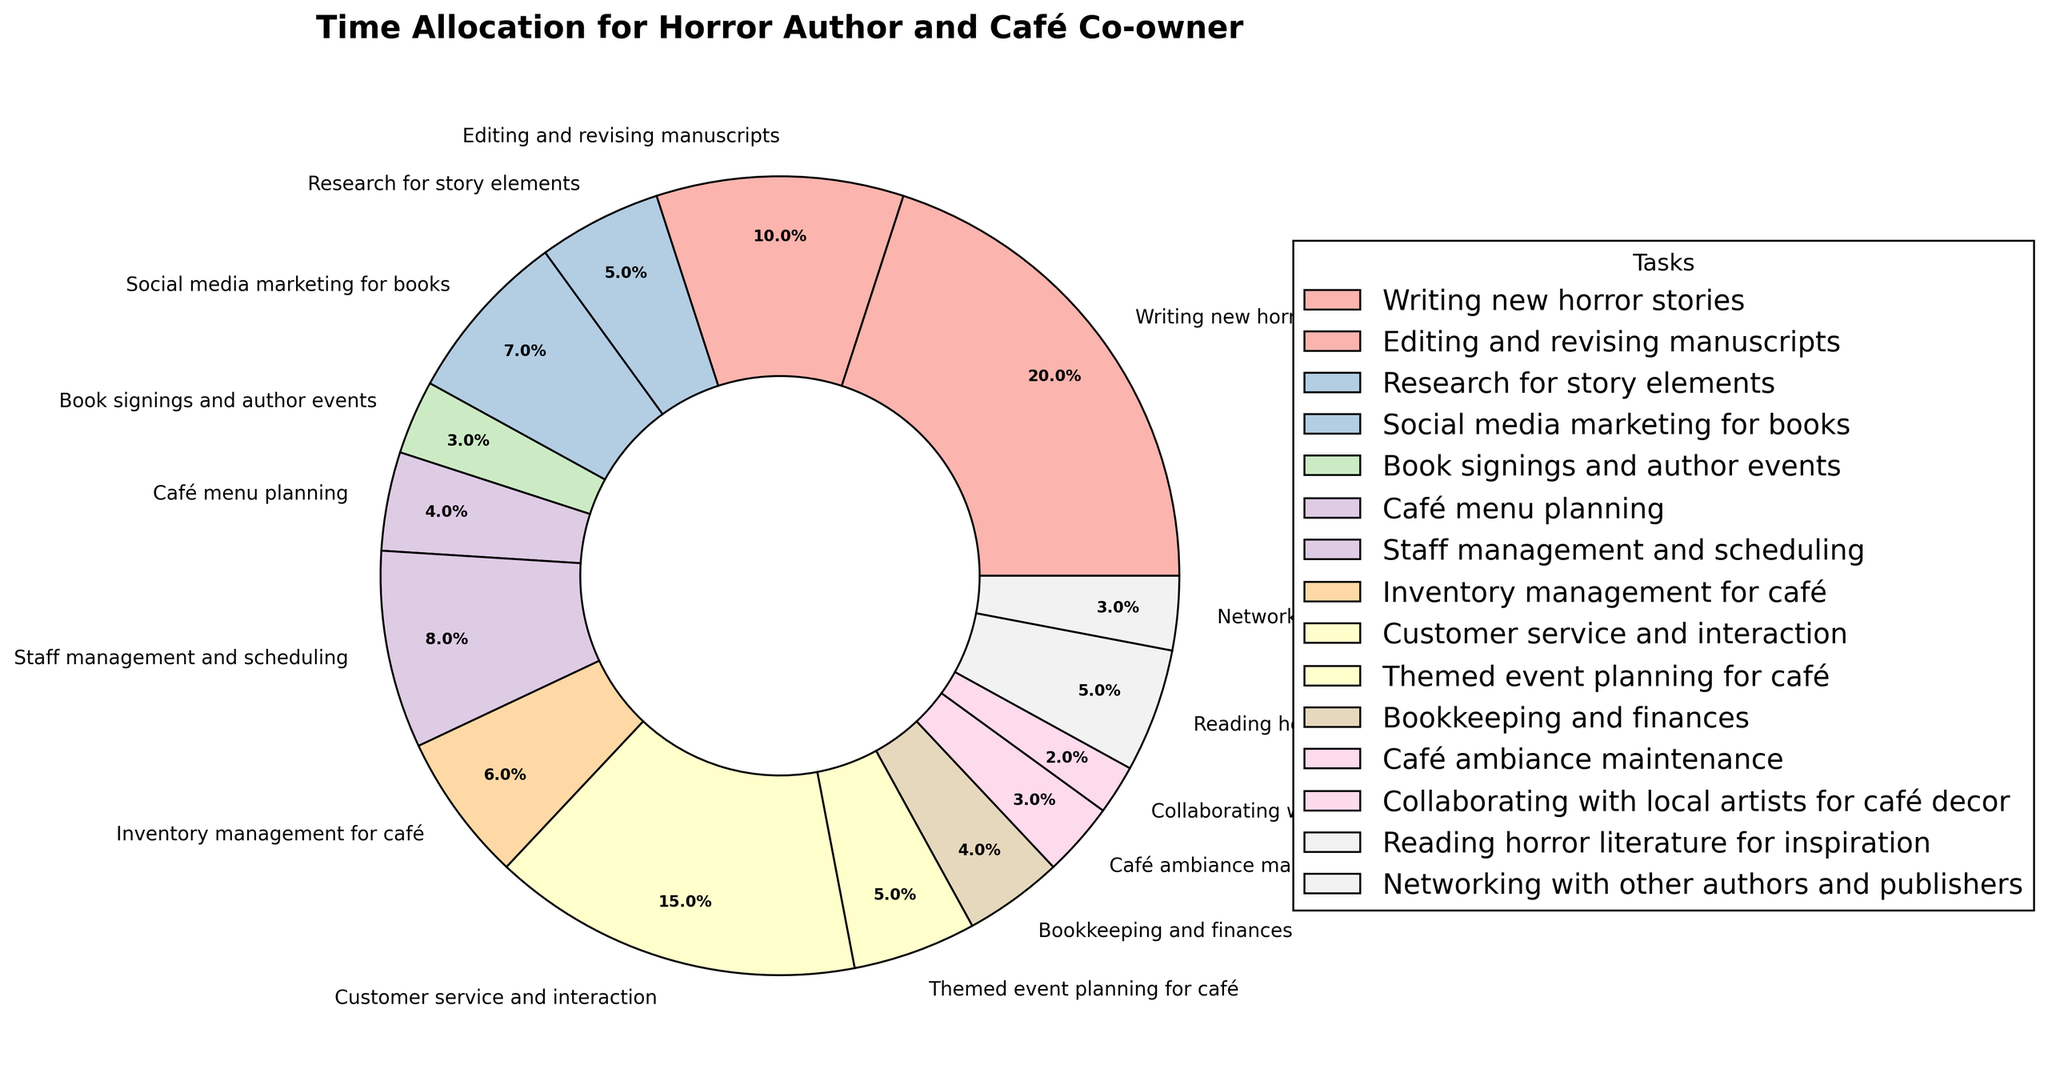How many tasks take up more than 10% of the total time? First, we need to identify tasks with more than 10% allocation. The total hours are 100 per week, so 10% is 10 hours. Only two tasks exceed 10 hours: Writing new horror stories (20) and Customer service and interaction (15).
Answer: 2 Which task takes up the most time, and what percentage is it? By inspecting the pie chart, "Writing new horror stories" takes up the most time at 20 hours per week. To find the percentage: (20 hours / 100 total hours) * 100% = 20%.
Answer: Writing new horror stories, 20% What is the combined percentage for tasks related to café management? Identify related tasks: Café menu planning (4), Staff management and scheduling (8), Inventory management for café (6), Customer service and interaction (15), Themed event planning for café (5), Bookkeeping and finances (4), Café ambiance maintenance (3), Collaborating with local artists for café decor (2). Sum the hours: 4 + 8 + 6 + 15 + 5 + 4 + 3 + 2 = 47. Calculate percentage: (47 / 100) * 100% = 47%.
Answer: 47% Which activity related to being an author takes the least amount of time, and how much is it? Refer to the hours for author-related tasks. "Book signings and author events" and "Networking with other authors and publishers" each take 3 hours, the minimum among author-related tasks.
Answer: Book signings and author events; Networking with other authors and publishers, 3 hours each How does the time spent on customer interaction compare to that on staff management and scheduling? Customer service and interaction takes 15 hours while Staff management and scheduling takes 8 hours. So, Customer service and interaction time is greater.
Answer: Customer service and interaction takes 7 more hours What’s the ratio of time spent on editing to time spent on reading for inspiration? Time spent on editing and revising manuscripts is 10 hours, while time spent on reading horror literature for inspiration is 5 hours. The ratio is 10:5 or 2:1.
Answer: 2:1 If time on café menu planning and bookkeeping was increased by 50%, what would the new combined percentage for these two tasks be? Current hours: Café menu planning (4) and Bookkeeping (4). Increase both by 50%: Café menu planning (4 * 1.5 = 6) and Bookkeeping (4 * 1.5 = 6). New combined hours: 6 + 6 = 12. New percentage: (12 / 100) * 100% = 12%.
Answer: 12% How much more time is spent on writing new stories compared to research for story elements and collaboration with local artists combined? Writing new horror stories takes 20 hours. Research for story elements takes 5 hours, and collaborating with local artists for café decor takes 2 hours. Combined, they take 5 + 2 = 7 hours. Difference: 20 - 7 = 13 hours.
Answer: 13 hours Considering only tasks related to the author role, what is the average number of hours spent per task? Author-related tasks: Writing new horror stories (20), Editing and revising manuscripts (10), Research for story elements (5), Social media marketing for books (7), Book signings and author events (3), Reading horror literature for inspiration (5), Networking with other authors and publishers (3). Total hours: 20 + 10 + 5 + 7 + 3 + 5 + 3 = 53. Number of tasks: 7. Average = 53 / 7 ≈ 7.57 hours.
Answer: ~7.57 hours 